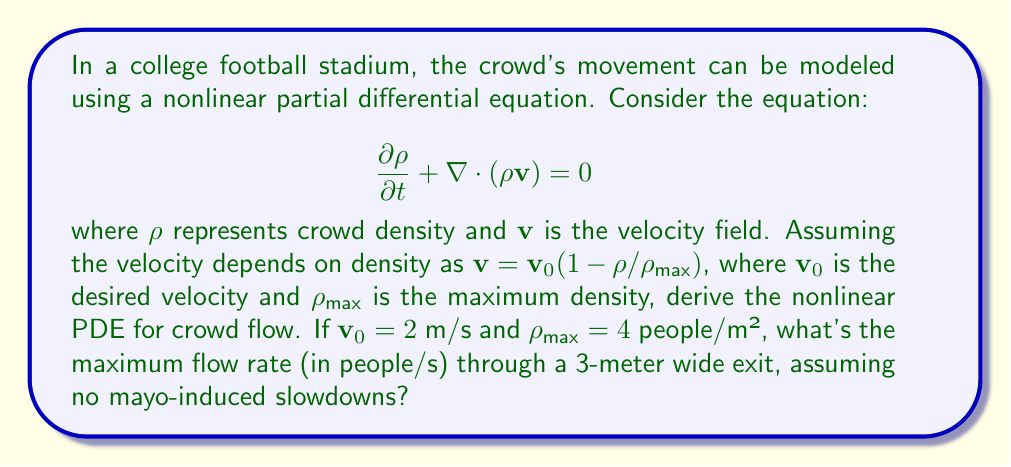Can you solve this math problem? Let's approach this step-by-step:

1) We start with the continuity equation:
   $$\frac{\partial \rho}{\partial t} + \nabla \cdot (\rho \mathbf{v}) = 0$$

2) Given $\mathbf{v} = \mathbf{v}_0(1 - \rho/\rho_{\text{max}})$, we substitute this into the equation:
   $$\frac{\partial \rho}{\partial t} + \nabla \cdot (\rho \mathbf{v}_0(1 - \rho/\rho_{\text{max}})) = 0$$

3) Expanding the divergence term:
   $$\frac{\partial \rho}{\partial t} + \mathbf{v}_0 \cdot \nabla \rho - \frac{\mathbf{v}_0}{\rho_{\text{max}}} \cdot \nabla (\rho^2) = 0$$

4) This is our nonlinear PDE for crowd flow.

5) To find the maximum flow rate, we need to calculate the maximum of $\rho \mathbf{v}$:
   $$\text{Flow} = \rho \mathbf{v} = \rho \mathbf{v}_0(1 - \rho/\rho_{\text{max}})$$

6) To find the maximum, we differentiate with respect to $\rho$ and set to zero:
   $$\frac{d}{d\rho}(\rho \mathbf{v}_0(1 - \rho/\rho_{\text{max}})) = \mathbf{v}_0(1 - 2\rho/\rho_{\text{max}}) = 0$$

7) Solving this, we get $\rho = \rho_{\text{max}}/2 = 2$ people/m²

8) The maximum flow rate per unit width is:
   $$\text{Max Flow Rate} = 2 \cdot 2 \cdot (1 - 2/4) = 2 \text{ people/(m·s)}$$

9) For a 3-meter wide exit, the total maximum flow rate is:
   $$\text{Total Max Flow Rate} = 2 \cdot 3 = 6 \text{ people/s}$$
Answer: 6 people/s 